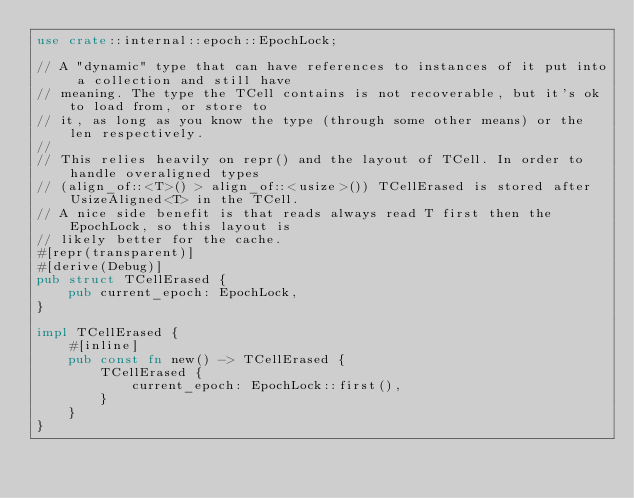<code> <loc_0><loc_0><loc_500><loc_500><_Rust_>use crate::internal::epoch::EpochLock;

// A "dynamic" type that can have references to instances of it put into a collection and still have
// meaning. The type the TCell contains is not recoverable, but it's ok to load from, or store to
// it, as long as you know the type (through some other means) or the len respectively.
//
// This relies heavily on repr() and the layout of TCell. In order to handle overaligned types
// (align_of::<T>() > align_of::<usize>()) TCellErased is stored after UsizeAligned<T> in the TCell.
// A nice side benefit is that reads always read T first then the EpochLock, so this layout is
// likely better for the cache.
#[repr(transparent)]
#[derive(Debug)]
pub struct TCellErased {
    pub current_epoch: EpochLock,
}

impl TCellErased {
    #[inline]
    pub const fn new() -> TCellErased {
        TCellErased {
            current_epoch: EpochLock::first(),
        }
    }
}
</code> 